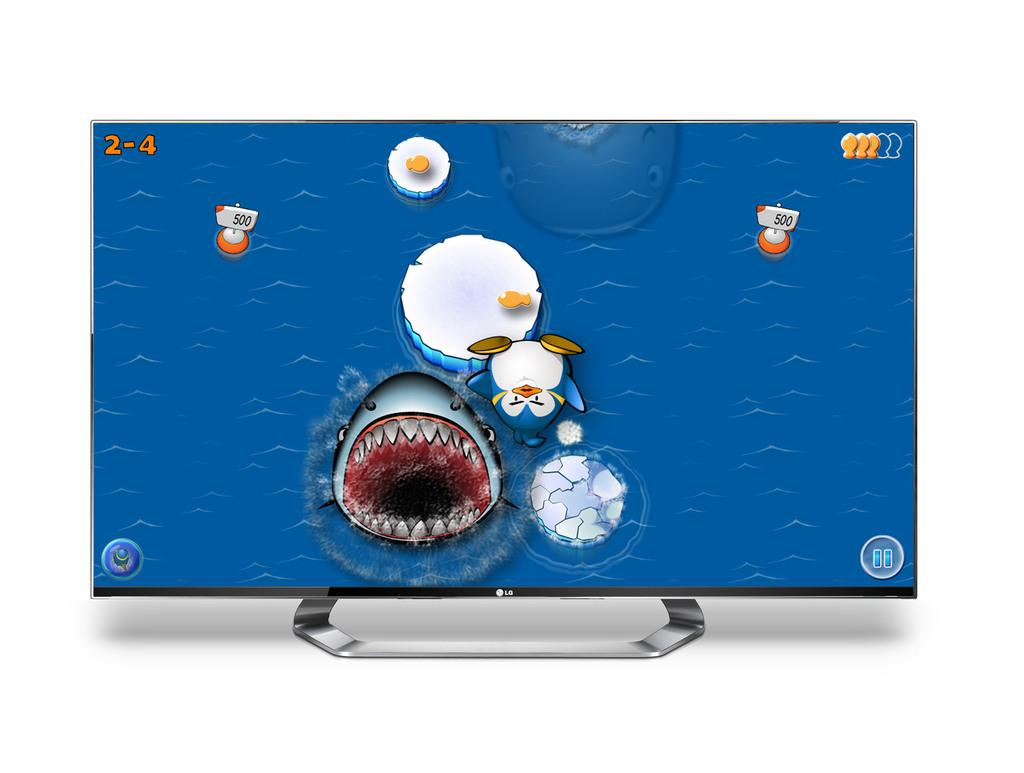Provide a one-sentence caption for the provided image. A computer game is displayed on a LG display monitor. 